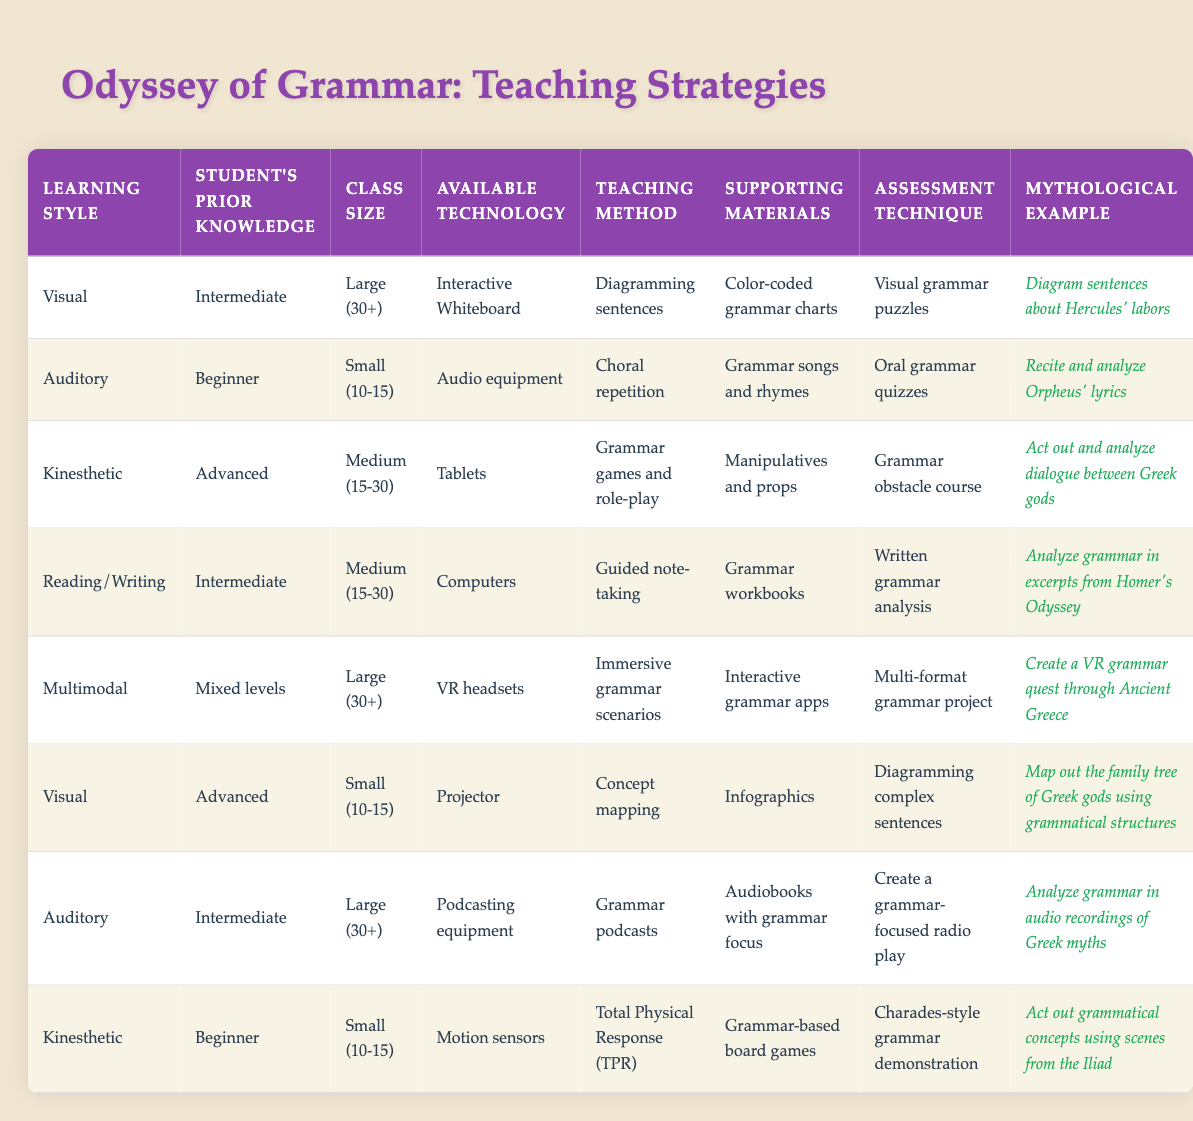What teaching method is suggested for auditory learners with beginner knowledge? According to the table, the recommended teaching method for auditory learners with beginner knowledge is choral repetition. This is found in the second row where it specifically lists "Choral repetition" as the teaching method under those conditions.
Answer: Choral repetition How many teaching methods are suitable for visual learners? The table contains two entries for visual learners: one for intermediate knowledge and large class size, and the other for advanced knowledge and small class size. Therefore, there are two distinct teaching methods suggested for visual learners.
Answer: 2 Is "Grammar obstacle course" used as an assessment technique for any learning styles? Yes, the assessment technique "Grammar obstacle course" is associated with kinesthetic learners with advanced knowledge. This can be confirmed by checking the entries related to kinesthetic learners, where this specific technique is listed.
Answer: Yes What is the average class size for teaching methods suggested for auditory learners? There are two entries for auditory learners: one for a small class size (10-15) and another for a large class size (30+). To find the average, convert these sizes to numerical values: 12.5 (average of 10-15) and 30, then sum them (12.5 + 30 = 42.5) and divide by 2, resulting in an average of 21.25.
Answer: 21.25 Which learning style uses VR headsets for teaching and what is the associated assessment technique? The learning style using VR headsets is multimodal, as noted in the fifth row of the table. The associated assessment technique for this learning style is a multi-format grammar project, which is detailed in the same row.
Answer: Multimodal; Multi-format grammar project For auditory learners with intermediate knowledge, what type of supporting materials are used? The table shows that for auditory learners with intermediate knowledge, the supporting materials are audiobooks with grammar focus. This can be found in the row corresponding to auditory learners with intermediate setups.
Answer: Audiobooks with grammar focus What mythological example is given for kinesthetic learners with advanced prior knowledge? The mythological example for kinesthetic learners with advanced prior knowledge is "Act out and analyze dialogue between Greek gods." This is explicitly mentioned in the entry that corresponds to that learning style and knowledge level.
Answer: Act out and analyze dialogue between Greek gods Which teaching method is associated with reading/writing learners? The table indicates that the teaching method associated with reading/writing learners is guided note-taking, as found in the row for reading/writing learners with intermediate prior knowledge.
Answer: Guided note-taking 